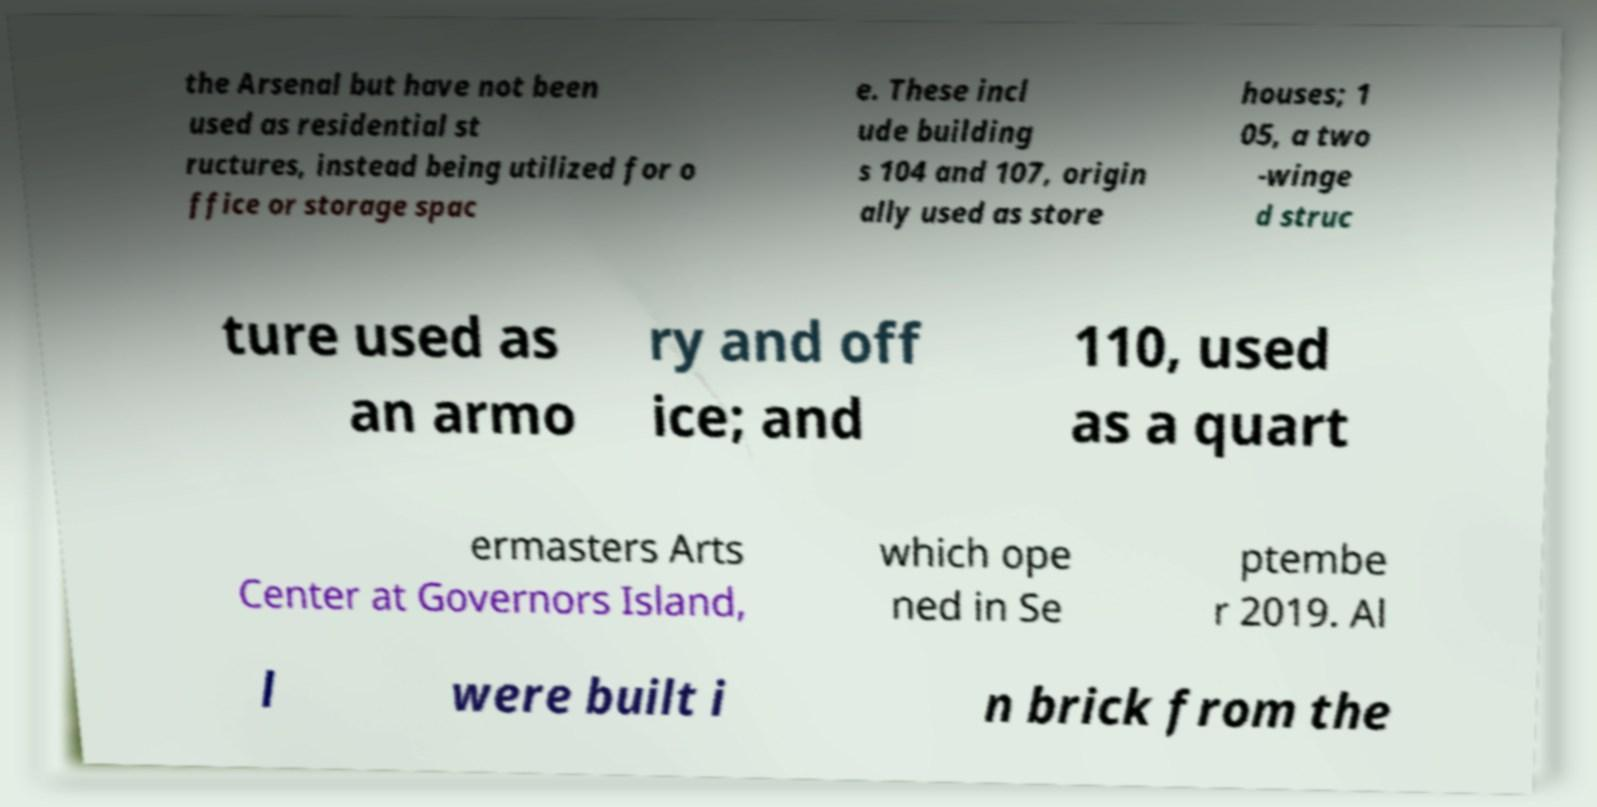There's text embedded in this image that I need extracted. Can you transcribe it verbatim? the Arsenal but have not been used as residential st ructures, instead being utilized for o ffice or storage spac e. These incl ude building s 104 and 107, origin ally used as store houses; 1 05, a two -winge d struc ture used as an armo ry and off ice; and 110, used as a quart ermasters Arts Center at Governors Island, which ope ned in Se ptembe r 2019. Al l were built i n brick from the 